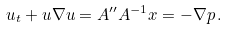<formula> <loc_0><loc_0><loc_500><loc_500>u _ { t } + u \nabla u = A ^ { \prime \prime } A ^ { - 1 } x = - \nabla p \, .</formula> 